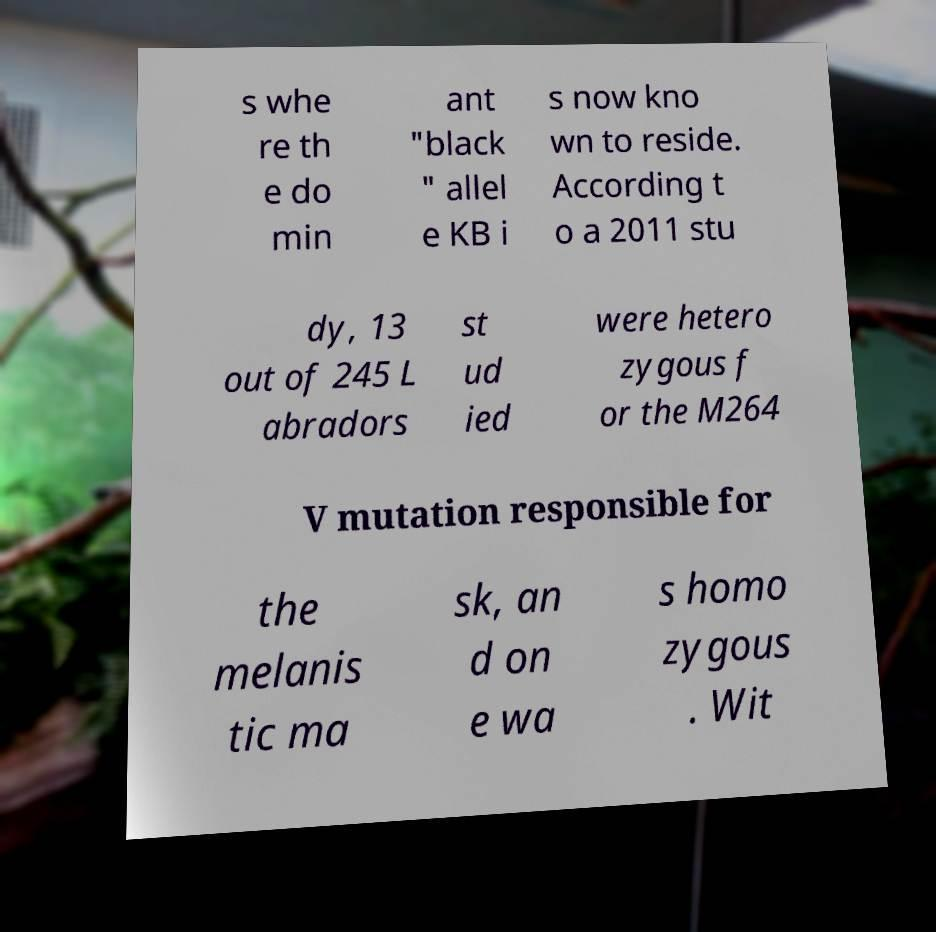Please identify and transcribe the text found in this image. s whe re th e do min ant "black " allel e KB i s now kno wn to reside. According t o a 2011 stu dy, 13 out of 245 L abradors st ud ied were hetero zygous f or the M264 V mutation responsible for the melanis tic ma sk, an d on e wa s homo zygous . Wit 